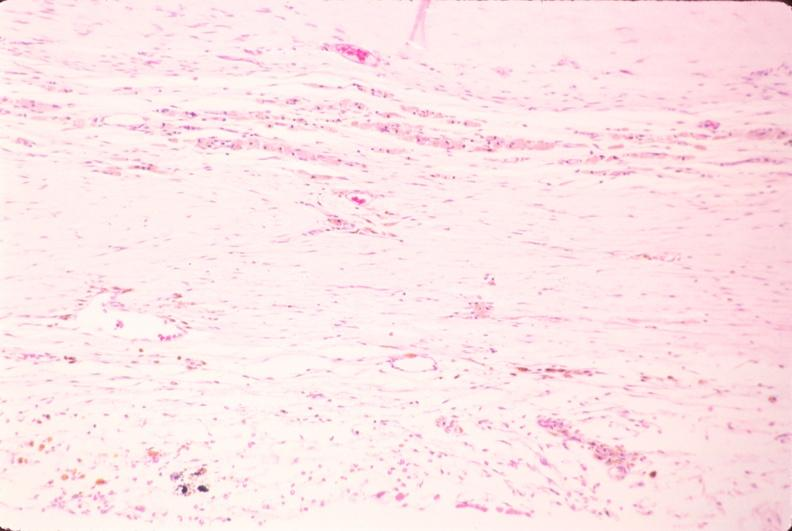why does this image show brain, infarct?
Answer the question using a single word or phrase. Due to ruptured saccular aneurysm and thrombosis of right middle cerebral artery 